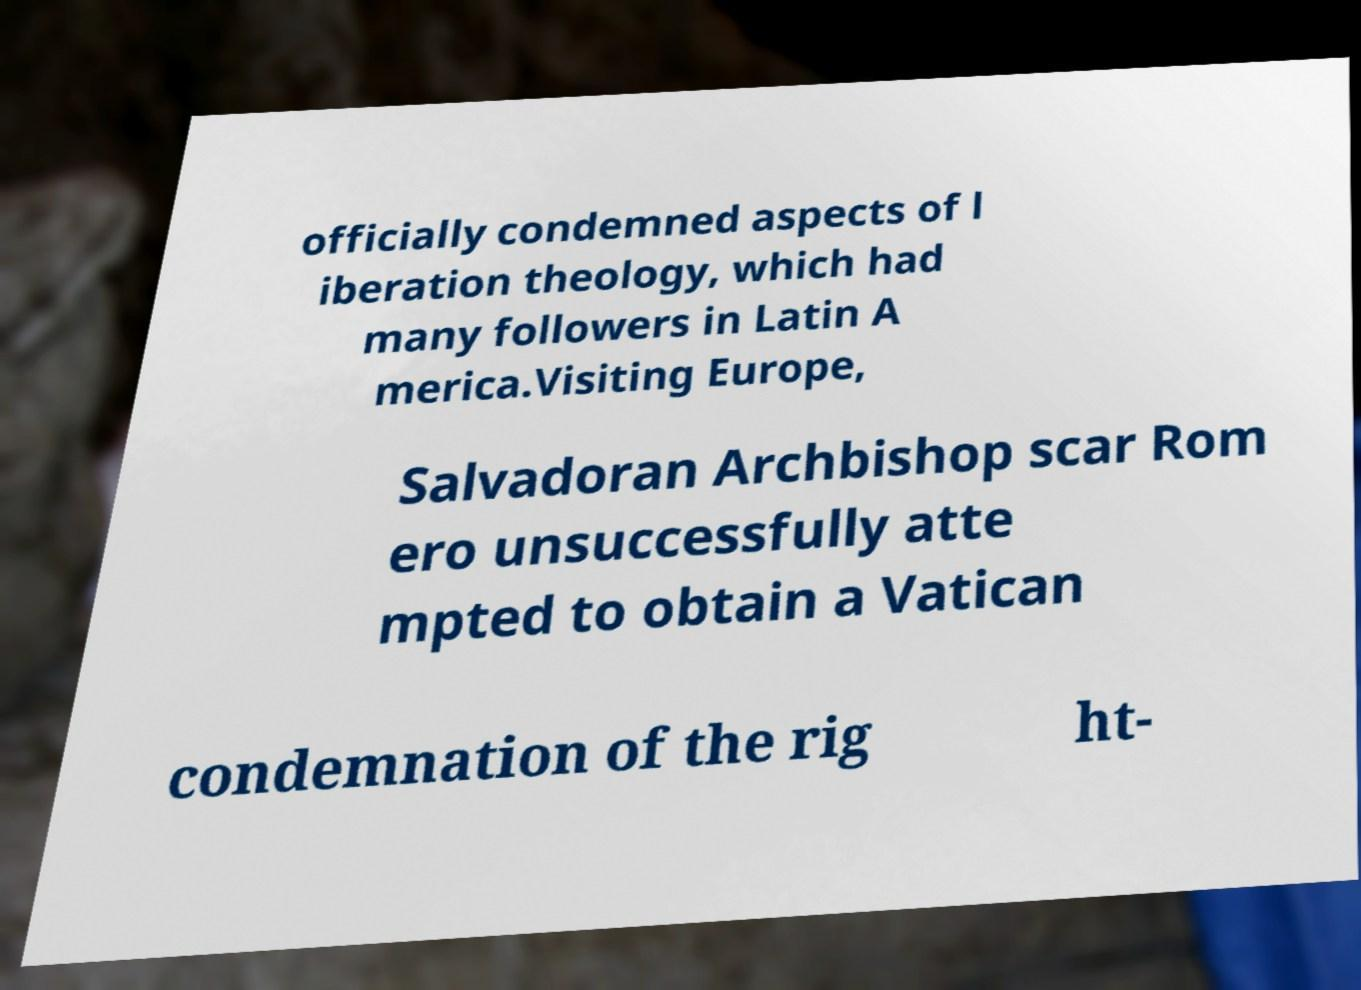I need the written content from this picture converted into text. Can you do that? officially condemned aspects of l iberation theology, which had many followers in Latin A merica.Visiting Europe, Salvadoran Archbishop scar Rom ero unsuccessfully atte mpted to obtain a Vatican condemnation of the rig ht- 